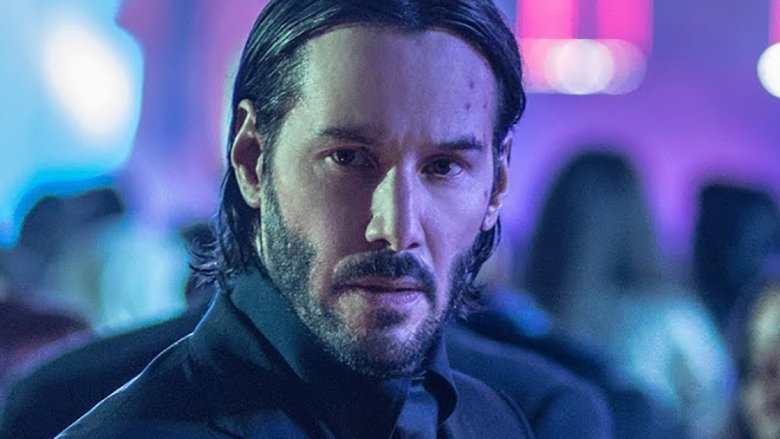What emotions does the man's expression convey? The man's expression conveys a mix of determination and introspection. His slightly furrowed brows and focused gaze suggest he is deeply involved in his thoughts, possibly contemplating a significant decision or reflecting on past events. 